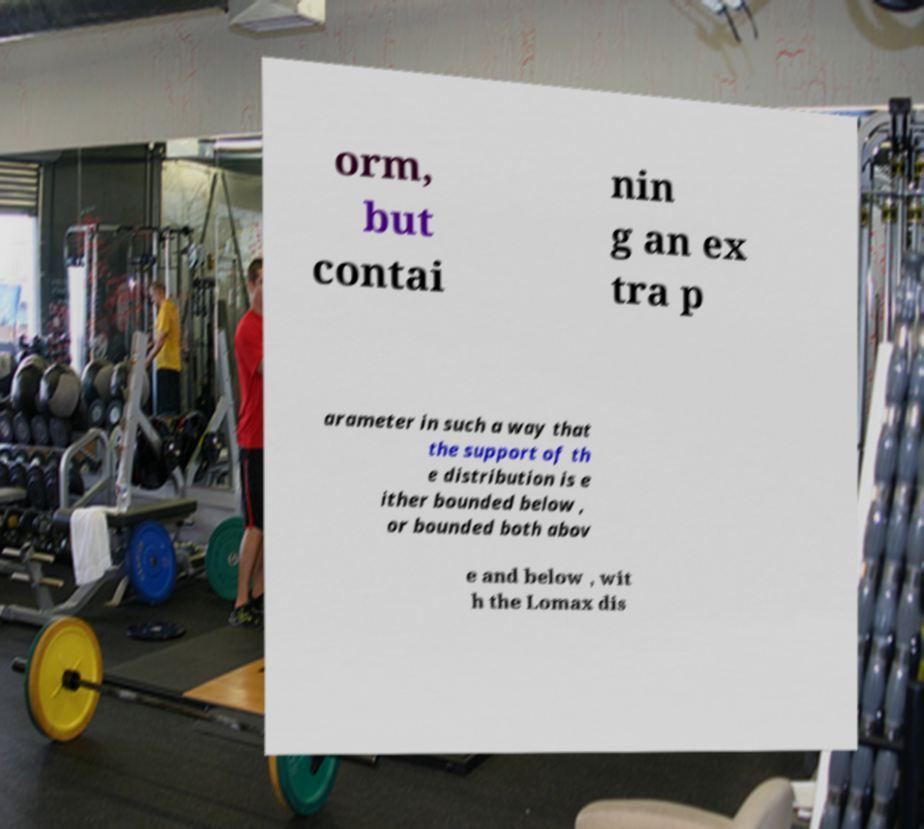What messages or text are displayed in this image? I need them in a readable, typed format. orm, but contai nin g an ex tra p arameter in such a way that the support of th e distribution is e ither bounded below , or bounded both abov e and below , wit h the Lomax dis 